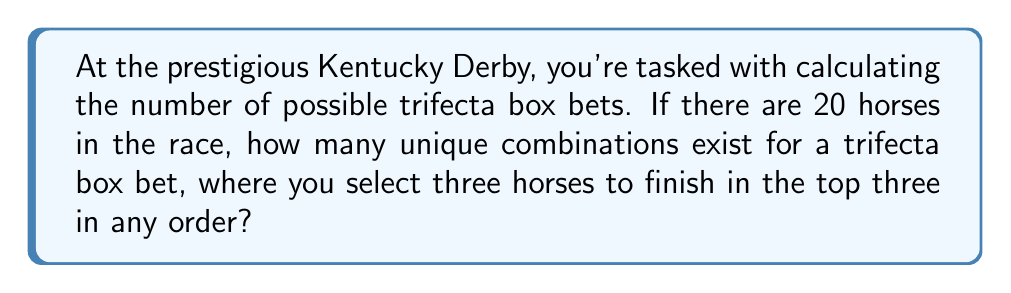Could you help me with this problem? Let's approach this step-by-step:

1) A trifecta box bet involves selecting three horses to finish in the top three positions in any order.

2) This is a combination problem, as the order doesn't matter (it's a "box" bet).

3) We're selecting 3 horses out of 20, which is represented by the combination formula:

   $$\binom{20}{3} = \frac{20!}{3!(20-3)!} = \frac{20!}{3!17!}$$

4) Let's calculate this:
   
   $$\frac{20 * 19 * 18 * 17!}{(3 * 2 * 1) * 17!}$$

5) The 17! cancels out in the numerator and denominator:

   $$\frac{20 * 19 * 18}{3 * 2 * 1} = \frac{6840}{6} = 1140$$

Therefore, there are 1140 possible combinations for a trifecta box bet with 20 horses.
Answer: 1140 